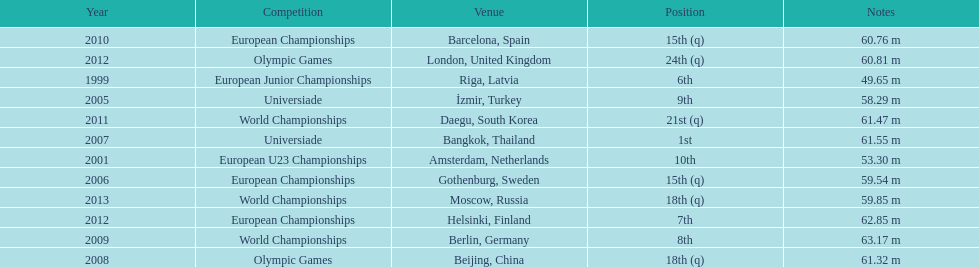Which year held the most competitions? 2012. 